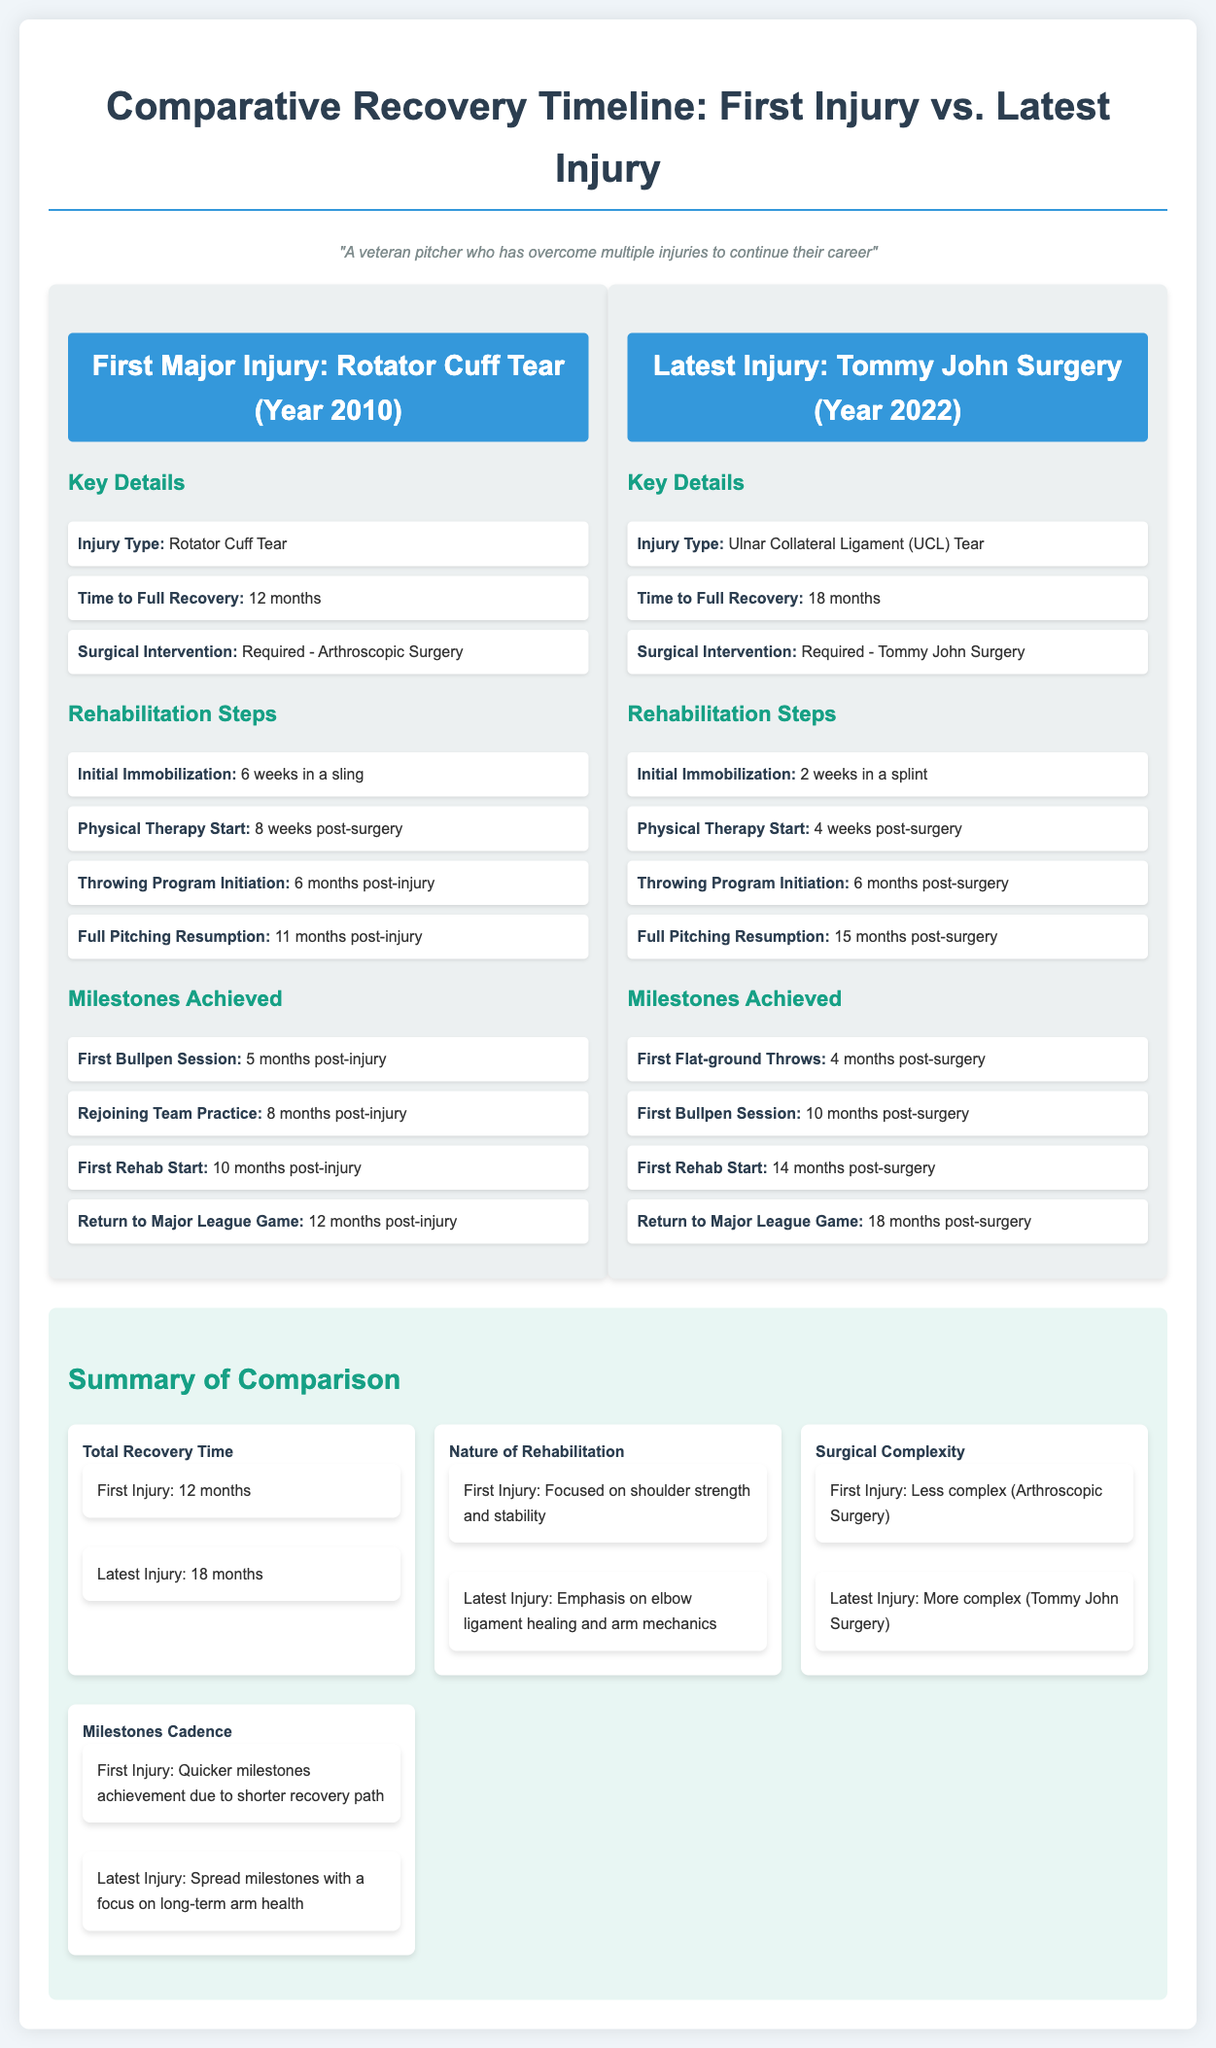What was the first injury? The document states the first major injury was a Rotator Cuff Tear.
Answer: Rotator Cuff Tear What year did the latest injury occur? The latest injury, Tommy John Surgery, occurred in the year 2022 as mentioned in the document.
Answer: 2022 How long did recovery take for the first injury? The document specifies that the time to full recovery for the first injury was 12 months.
Answer: 12 months What kind of surgical intervention was required for the latest injury? The document indicates that the surgical intervention for the latest injury was Tommy John Surgery.
Answer: Tommy John Surgery What was the initial immobilization period for the first injury? The document notes that the initial immobilization for the first injury was 6 weeks in a sling.
Answer: 6 weeks in a sling How does the total recovery time compare between the two injuries? The document compares total recovery times for both injuries, showing the latest injury took longer to recover at 18 months.
Answer: 18 months Which injury had a more complex surgical requirement? The document specifies that the latest injury involved a more complex surgery compared to the first injury.
Answer: Latest Injury What milestone was achieved first for the latest injury? The document states the first milestone achieved for the latest injury was Flat-ground Throws, occurring 4 months post-surgery.
Answer: First Flat-ground Throws What is emphasized in the rehabilitation for the latest injury? The document emphasizes that rehabilitation for the latest injury focused on elbow ligament healing and arm mechanics.
Answer: Elbow ligament healing and arm mechanics 